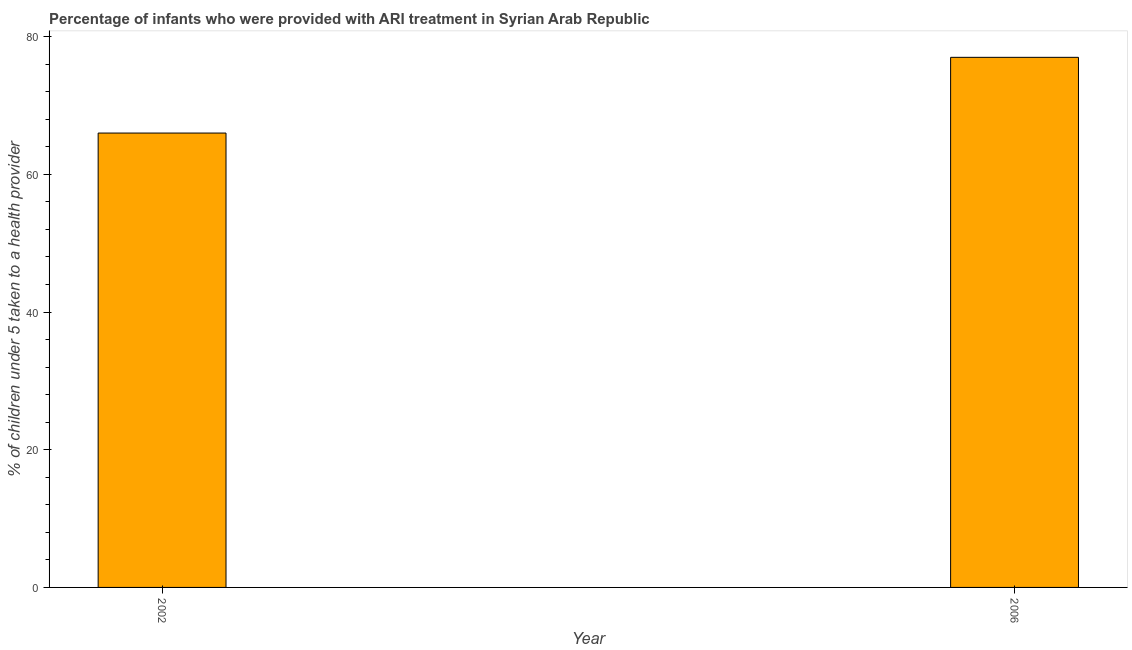What is the title of the graph?
Offer a very short reply. Percentage of infants who were provided with ARI treatment in Syrian Arab Republic. What is the label or title of the X-axis?
Make the answer very short. Year. What is the label or title of the Y-axis?
Offer a very short reply. % of children under 5 taken to a health provider. Across all years, what is the minimum percentage of children who were provided with ari treatment?
Give a very brief answer. 66. In which year was the percentage of children who were provided with ari treatment maximum?
Provide a succinct answer. 2006. In which year was the percentage of children who were provided with ari treatment minimum?
Your answer should be very brief. 2002. What is the sum of the percentage of children who were provided with ari treatment?
Keep it short and to the point. 143. What is the difference between the percentage of children who were provided with ari treatment in 2002 and 2006?
Your response must be concise. -11. What is the average percentage of children who were provided with ari treatment per year?
Make the answer very short. 71. What is the median percentage of children who were provided with ari treatment?
Offer a terse response. 71.5. What is the ratio of the percentage of children who were provided with ari treatment in 2002 to that in 2006?
Ensure brevity in your answer.  0.86. In how many years, is the percentage of children who were provided with ari treatment greater than the average percentage of children who were provided with ari treatment taken over all years?
Give a very brief answer. 1. How many bars are there?
Make the answer very short. 2. Are all the bars in the graph horizontal?
Give a very brief answer. No. How many years are there in the graph?
Offer a terse response. 2. What is the difference between two consecutive major ticks on the Y-axis?
Give a very brief answer. 20. What is the difference between the % of children under 5 taken to a health provider in 2002 and 2006?
Ensure brevity in your answer.  -11. What is the ratio of the % of children under 5 taken to a health provider in 2002 to that in 2006?
Ensure brevity in your answer.  0.86. 